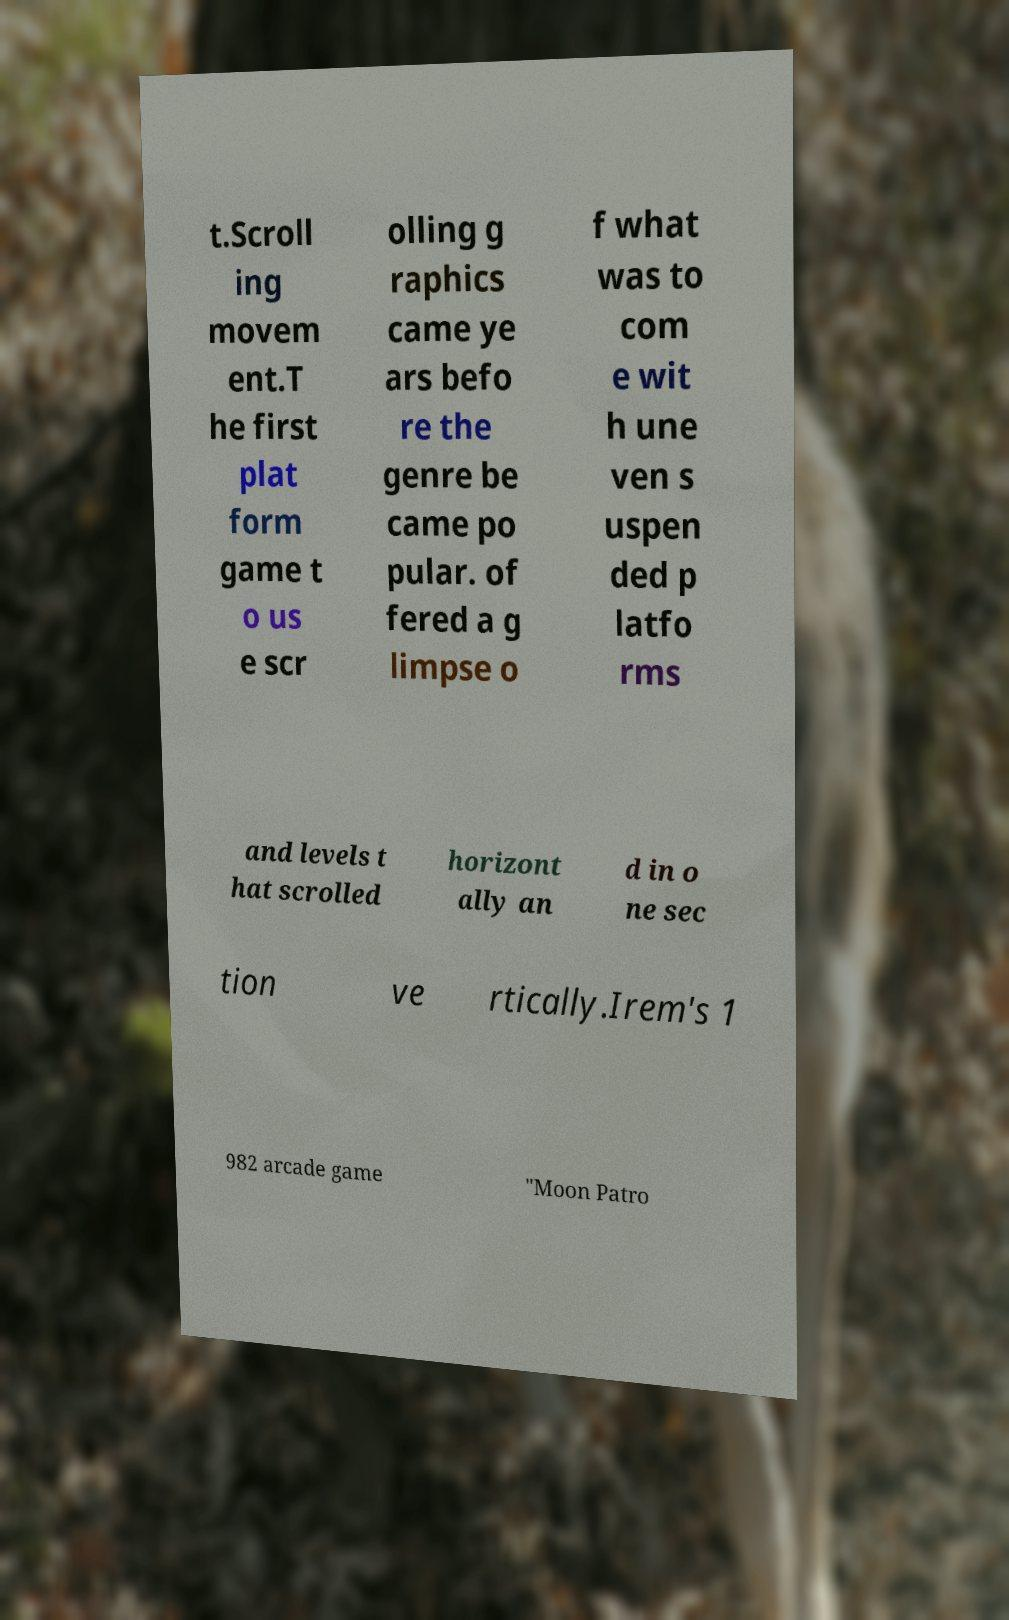There's text embedded in this image that I need extracted. Can you transcribe it verbatim? t.Scroll ing movem ent.T he first plat form game t o us e scr olling g raphics came ye ars befo re the genre be came po pular. of fered a g limpse o f what was to com e wit h une ven s uspen ded p latfo rms and levels t hat scrolled horizont ally an d in o ne sec tion ve rtically.Irem's 1 982 arcade game "Moon Patro 